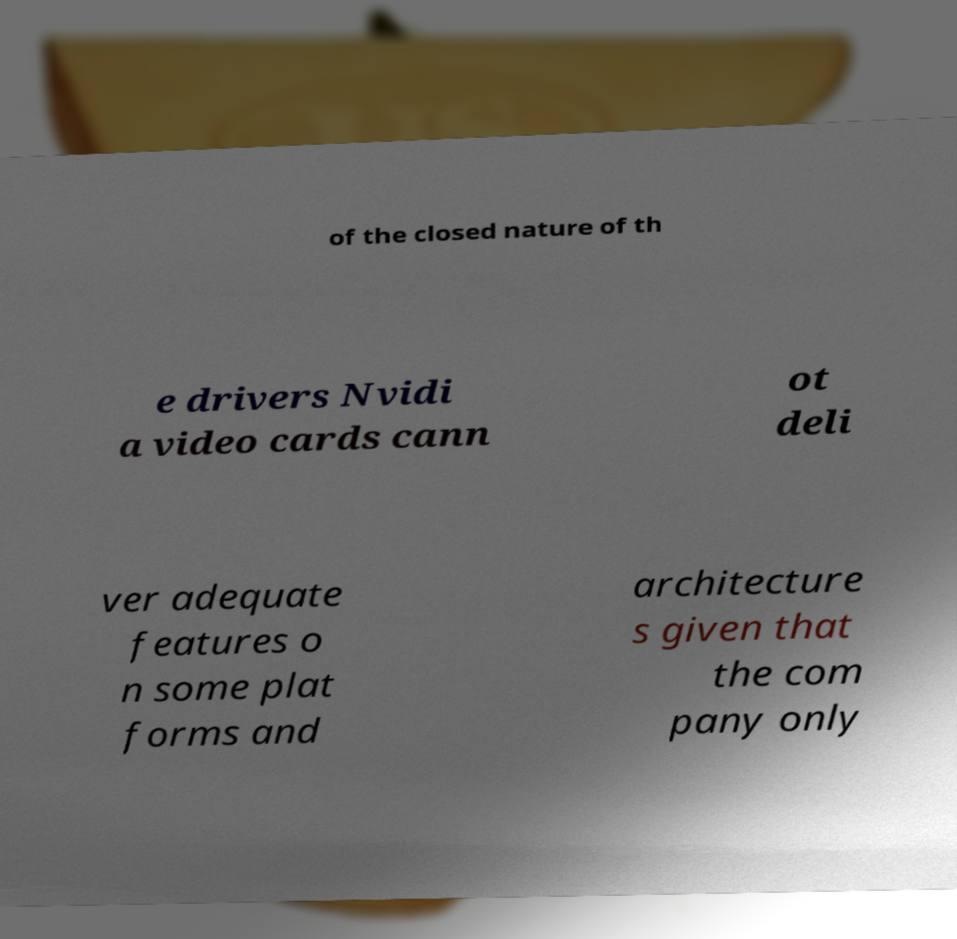Please read and relay the text visible in this image. What does it say? of the closed nature of th e drivers Nvidi a video cards cann ot deli ver adequate features o n some plat forms and architecture s given that the com pany only 